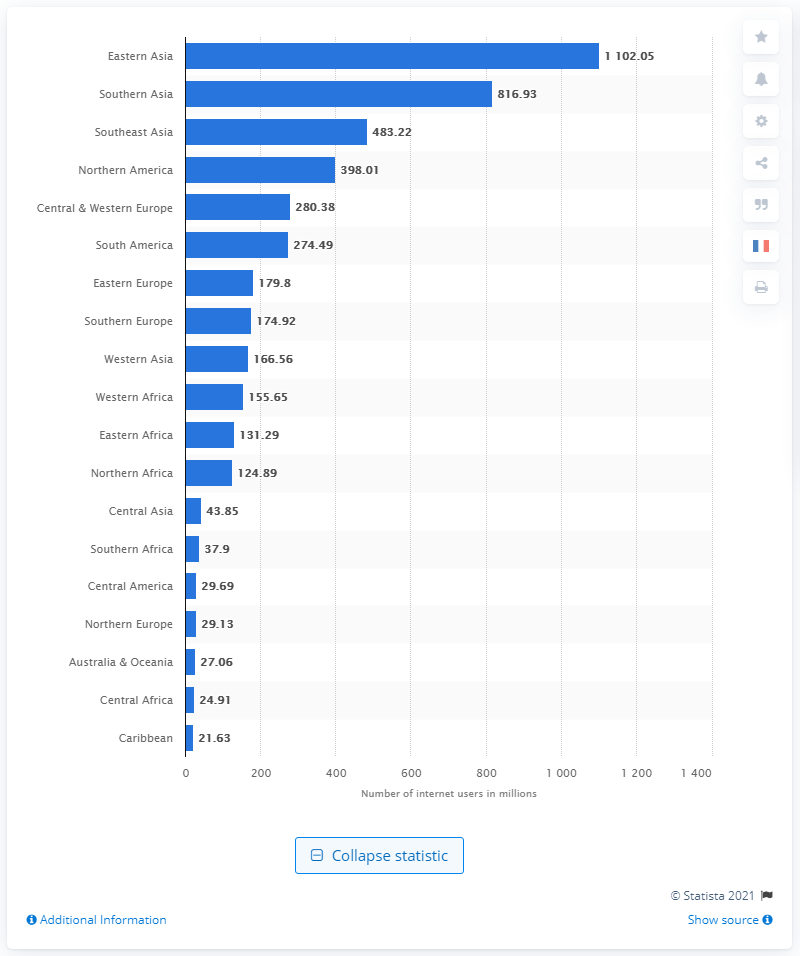Identify some key points in this picture. In 2020, the number of internet users in Southern Asia was approximately 816.93 million. In 2020, there were approximately 1,102.05 million internet users in East Asia. 